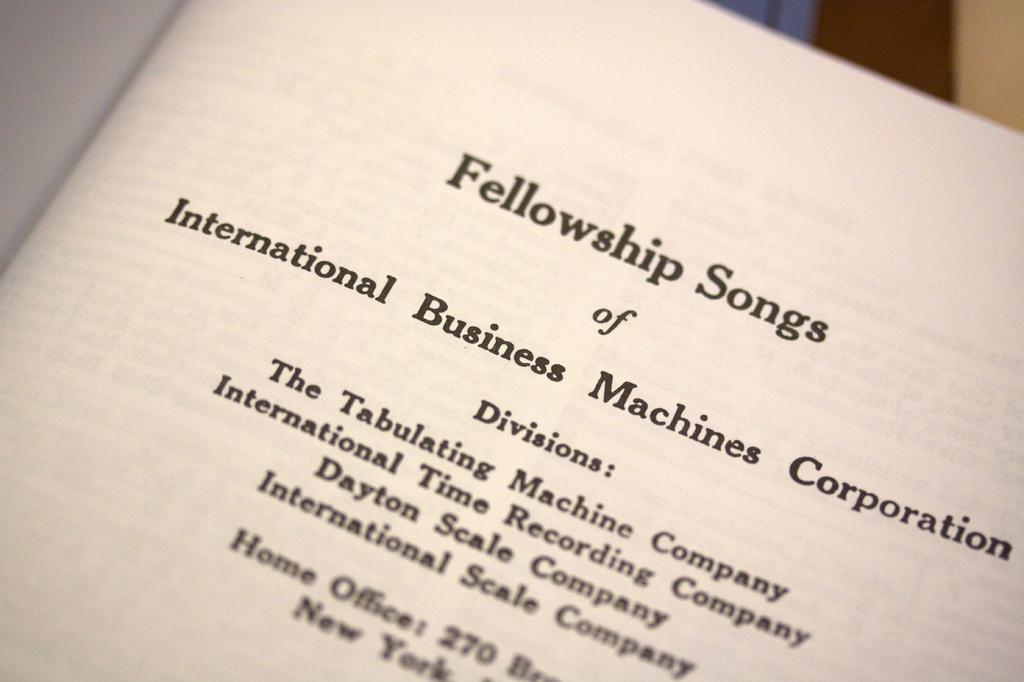<image>
Describe the image concisely. A paper that says Fellowship Songs at the top. 